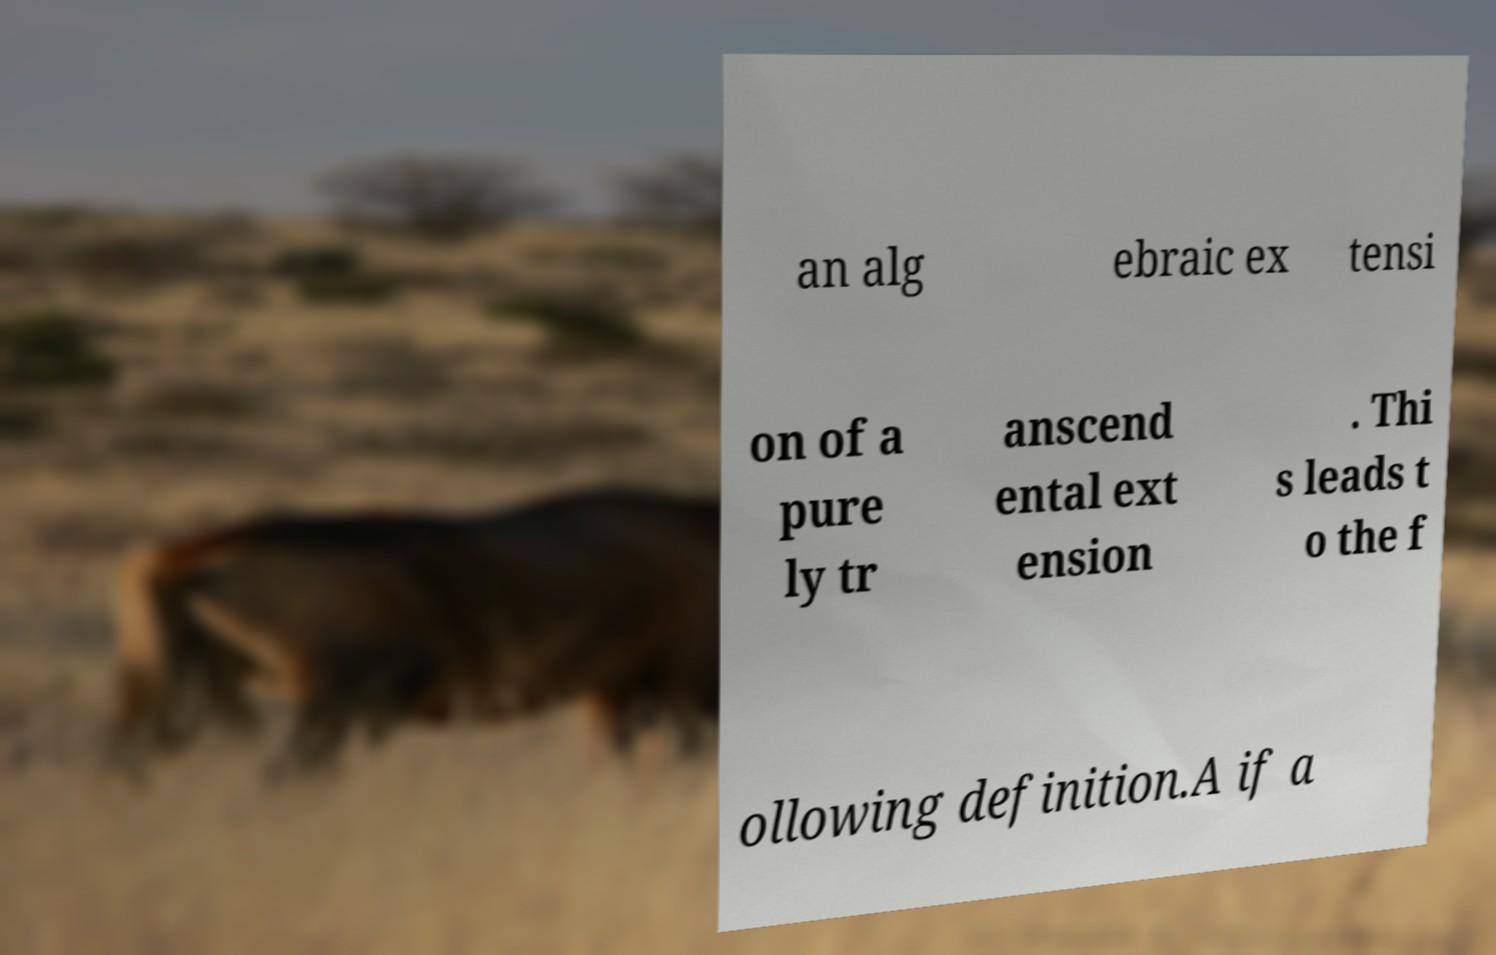Can you accurately transcribe the text from the provided image for me? an alg ebraic ex tensi on of a pure ly tr anscend ental ext ension . Thi s leads t o the f ollowing definition.A if a 